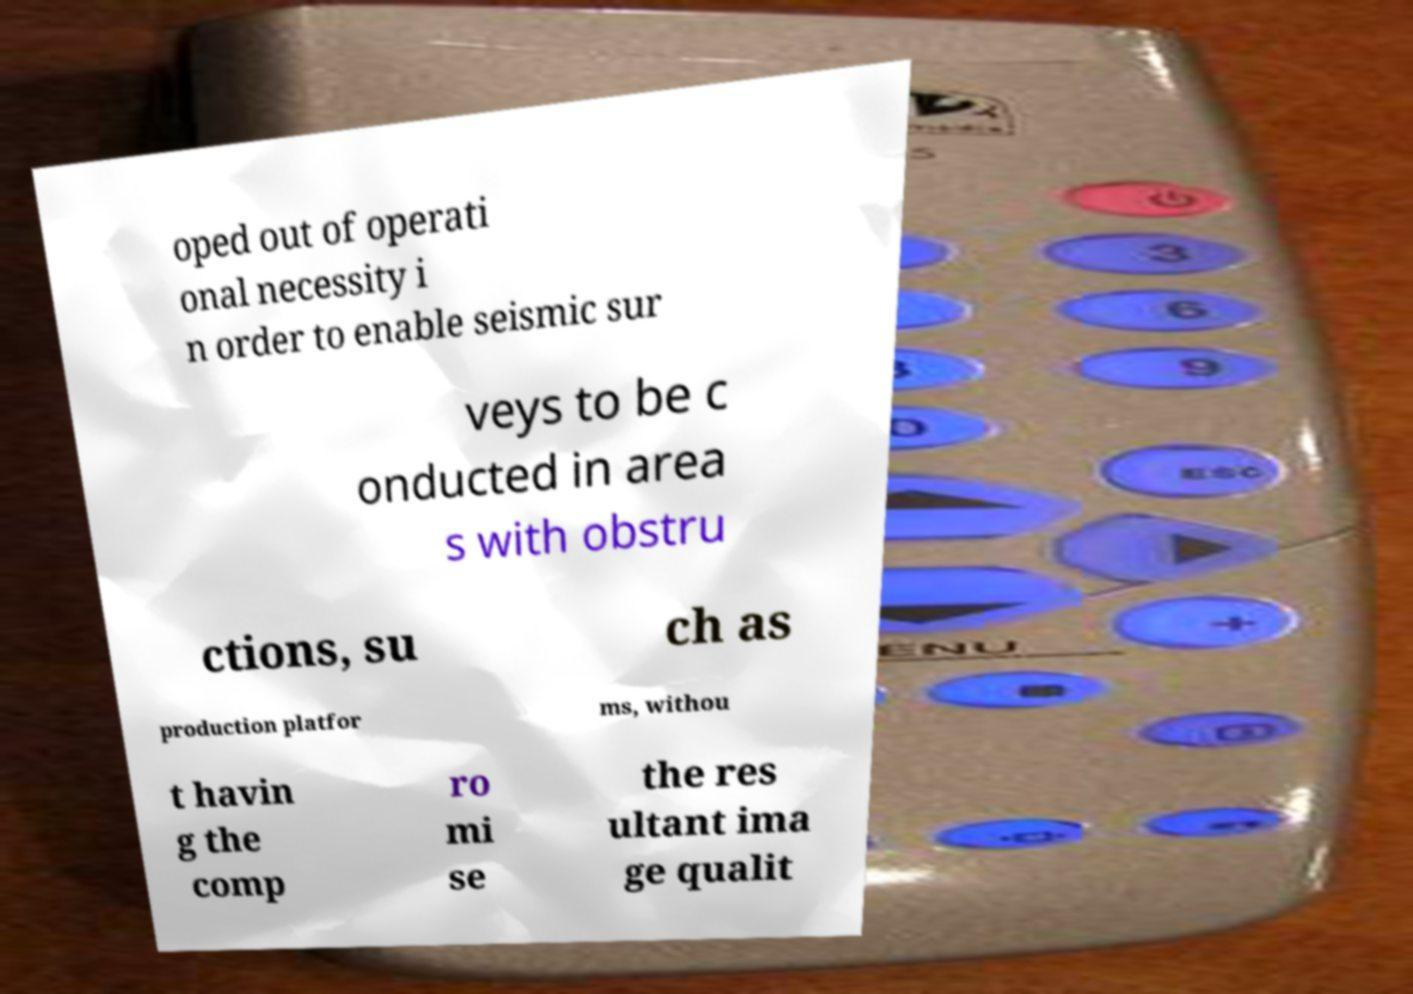Can you read and provide the text displayed in the image?This photo seems to have some interesting text. Can you extract and type it out for me? oped out of operati onal necessity i n order to enable seismic sur veys to be c onducted in area s with obstru ctions, su ch as production platfor ms, withou t havin g the comp ro mi se the res ultant ima ge qualit 